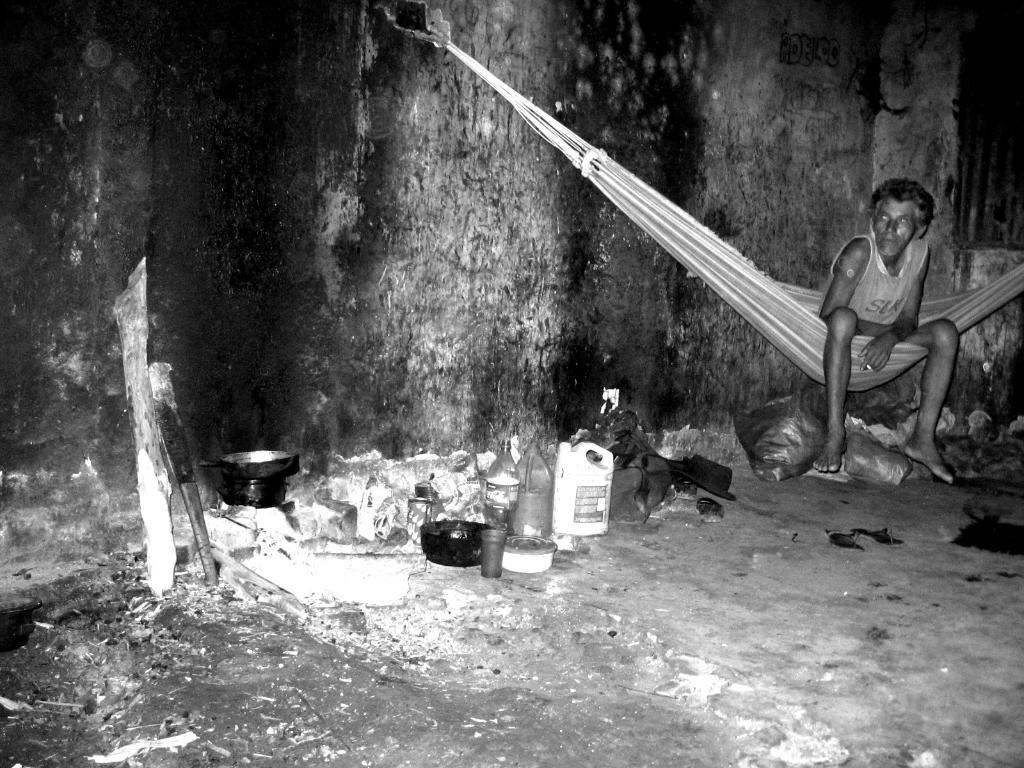What type of picture is in the image? The image contains a black and white picture. What is the person in the image doing? There is a person sitting on the ground in the image. What objects are on the ground near the person? There is a bowl, a glass, cans, and bags on the ground in the image. Are there any other objects visible on the ground? Yes, there are other objects on the ground in the image. What type of art can be seen on the walls in the image? The image does not show any walls or art on them, as it only contains a black and white picture, a person sitting on the ground, and various objects on the ground. 